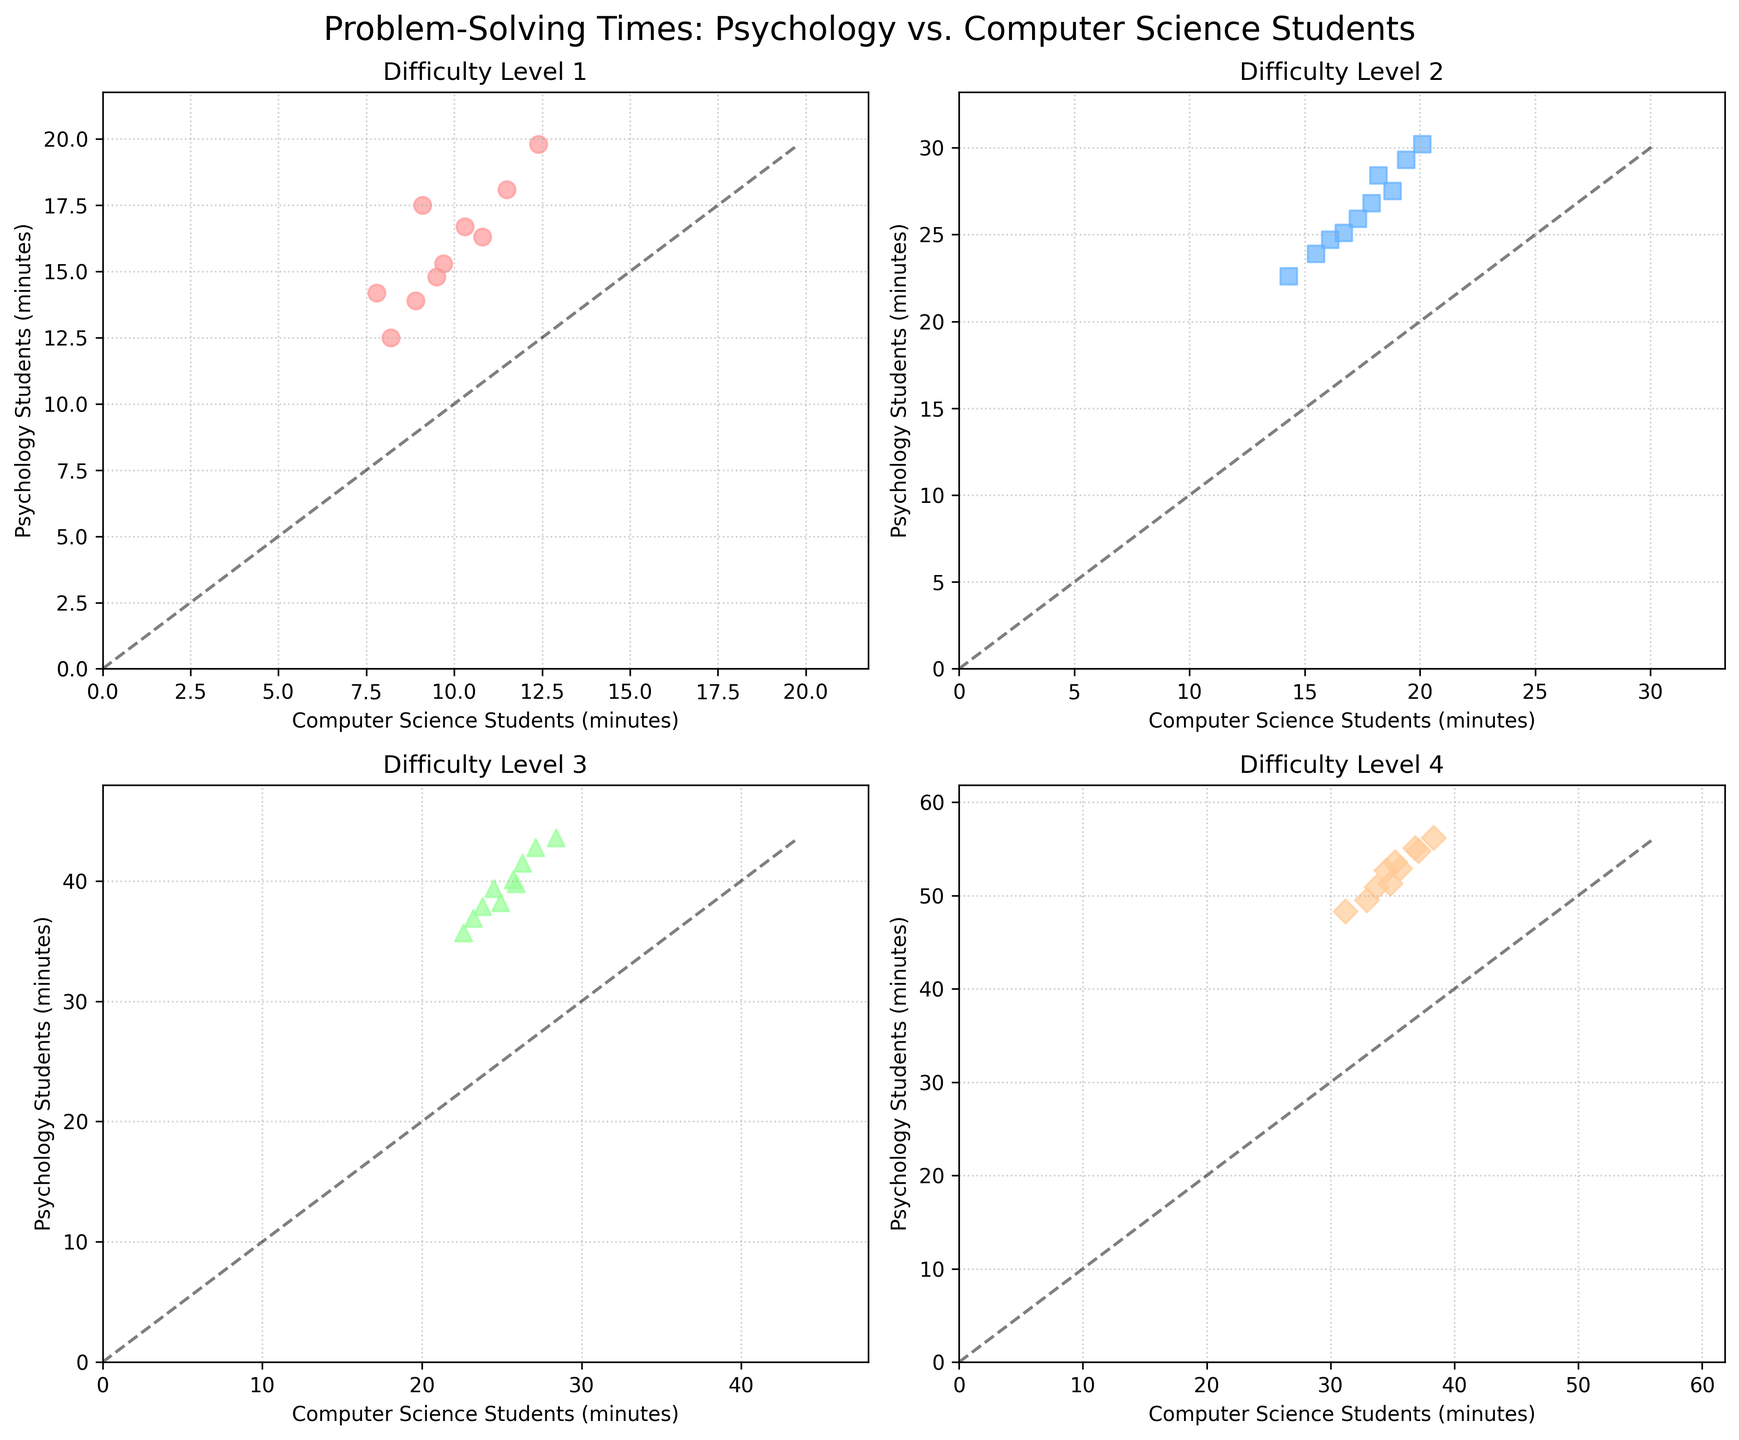What is the general trend observed when comparing problem-solving times for psychology and computer science students across different difficulty levels? Look at each subplot for all difficulty levels (1 to 4). Notice that in each subplot, the data points lie mostly above the dashed line (y = x), indicating that psychology students generally take longer to solve the challenges than computer science students.
Answer: Psychology students take longer In the plot for Difficulty Level 3, do psychology students take longer than computer science students for each individual data point? Focus on the subplot for Difficulty Level 3. Note that all the data points for psychology students are above the dashed line, meaning they always take longer than computer science students for this level of difficulty.
Answer: Yes How does the average time for computer science students change as the difficulty level increases from 1 to 4? Calculate and compare the average times for computer science students across the subplots for all difficulty levels. For Level 1, the average is ((8.2 + 9.7 + 11.5 + 7.8 + 10.3 + 8.9 + 9.1 + 12.4 + 10.8 + 9.5) / 10) = 9.82. Similarly, find averages for Level 2, Level 3, and Level 4. Notice that the average time increases as the difficulty level increases.
Answer: Average time increases Which difficulty level shows the most spread out data points for psychology students? Observe the vertical spread of data points for psychology students across all difficulties. Level 4 shows a broader range of problem-solving times from 48.3 to 56.2 minutes, indicating the most spread out data points.
Answer: Difficulty Level 4 Can you infer any outliers for either group in any of the subplots? Look for data points that are significantly distant from the majority for both psychology and computer science students. There are no clear data points standing significantly apart from the rest in any subplot, so there are no obvious outliers.
Answer: No outliers What is the approximate time difference between psychology and computer science students for the highest difficulty level (Level 4)? In the subplot for Difficulty Level 4, find the average time for both groups. For psychology students: (48.3 + 52.7 + 55.1 + 50.9 + 53.6 + 49.5 + 54.8 + 51.3 + 56.2 + 52.9) / 10 = 52.73. For computer science students: (31.2 + 34.5 + 36.8 + 33.7 + 35.2 + 32.9 + 37.1 + 34.8 + 38.3 + 35.6) = 35.01. The difference is 52.73 - 35.01 = 17.72 minutes.
Answer: ~17.72 minutes Which difficulty level shows the closest problem-solving times between psychology and computer science students? Compare the proximity of the data points to the dashed line across all difficulty levels. Difficulty Level 1 shows data points that are relatively closer together, indicating that problem-solving times are more similar between the two groups for this level.
Answer: Difficulty Level 1 